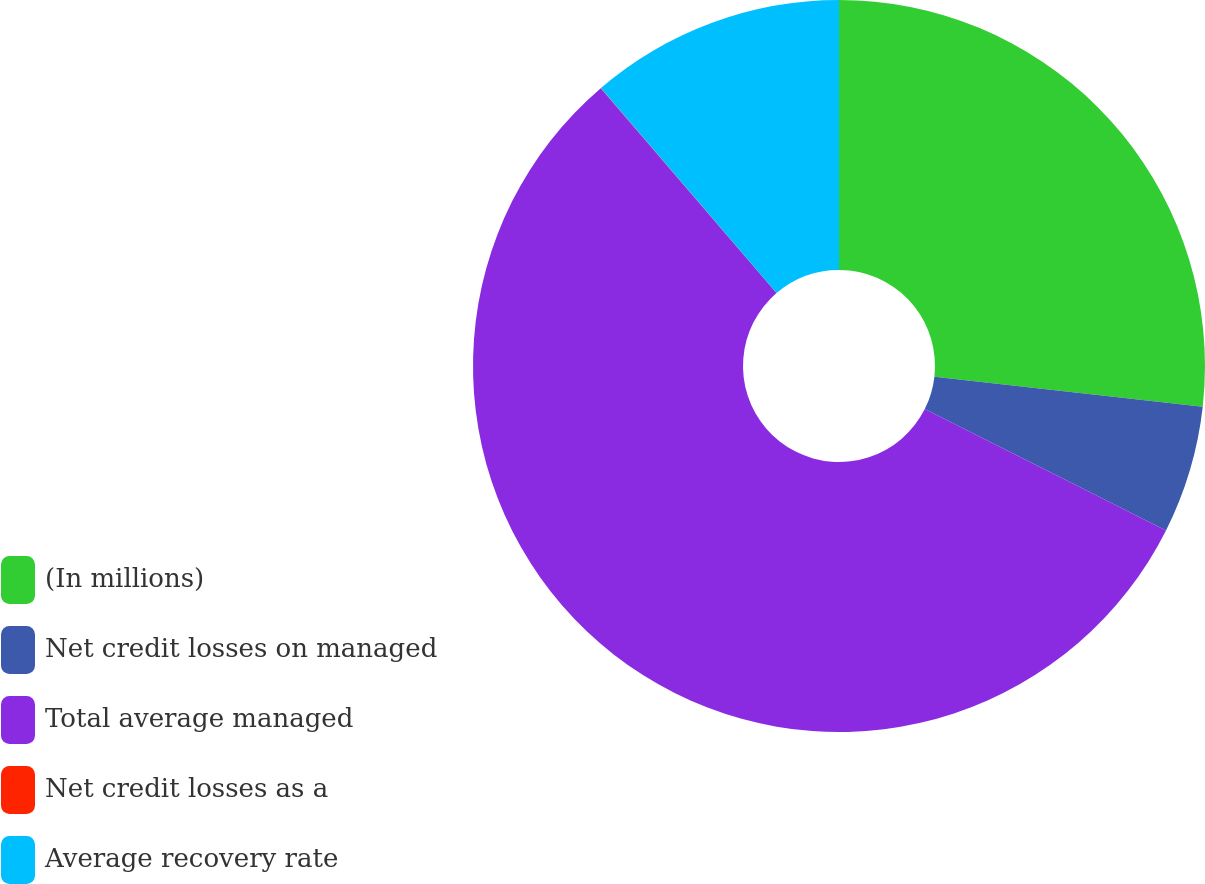<chart> <loc_0><loc_0><loc_500><loc_500><pie_chart><fcel>(In millions)<fcel>Net credit losses on managed<fcel>Total average managed<fcel>Net credit losses as a<fcel>Average recovery rate<nl><fcel>26.77%<fcel>5.64%<fcel>56.3%<fcel>0.01%<fcel>11.27%<nl></chart> 